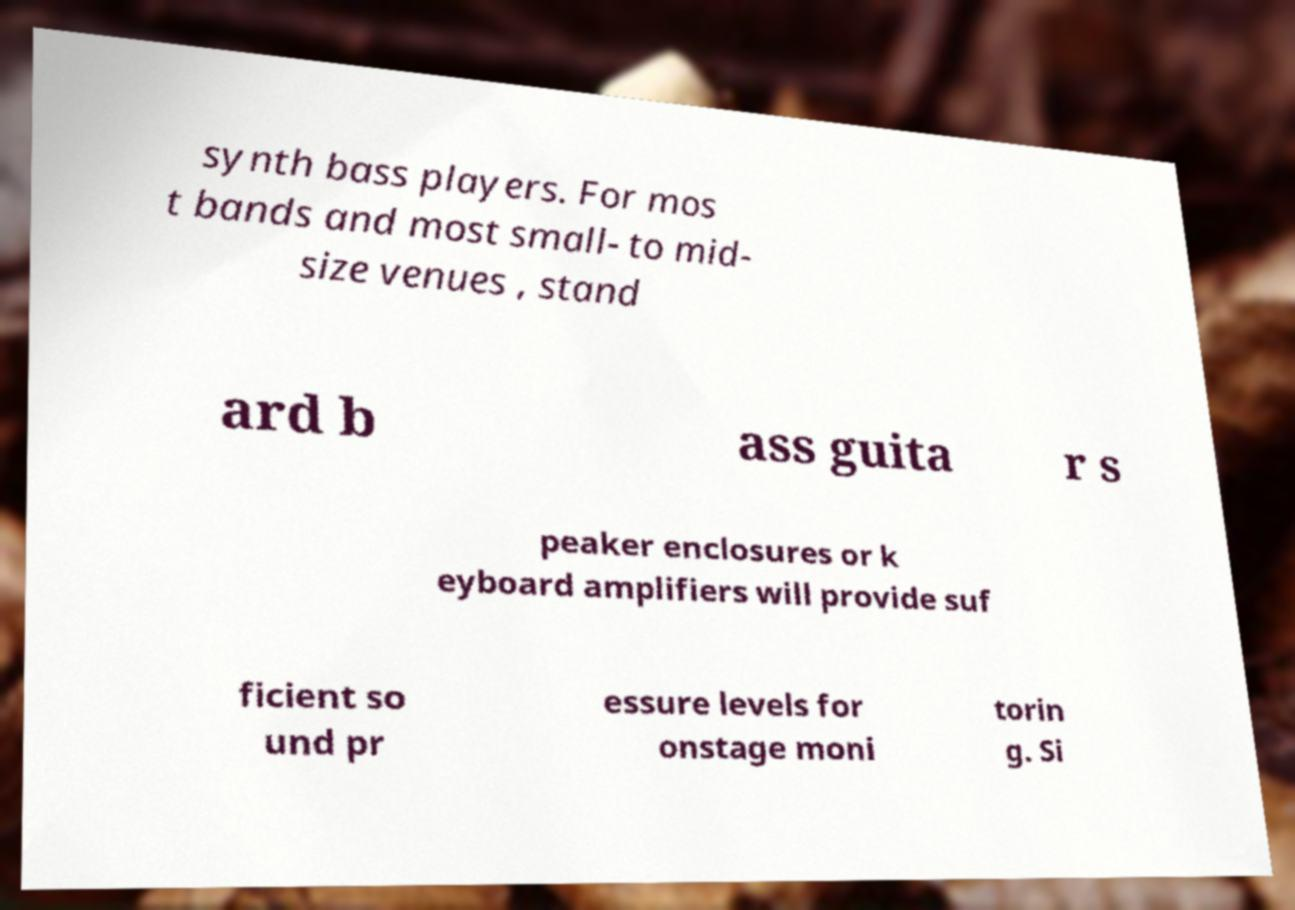Please read and relay the text visible in this image. What does it say? synth bass players. For mos t bands and most small- to mid- size venues , stand ard b ass guita r s peaker enclosures or k eyboard amplifiers will provide suf ficient so und pr essure levels for onstage moni torin g. Si 